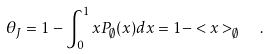<formula> <loc_0><loc_0><loc_500><loc_500>\theta _ { J } = 1 - \int _ { 0 } ^ { 1 } x P _ { \emptyset } ( x ) d x = 1 - < x > _ { \emptyset } \ \ .</formula> 